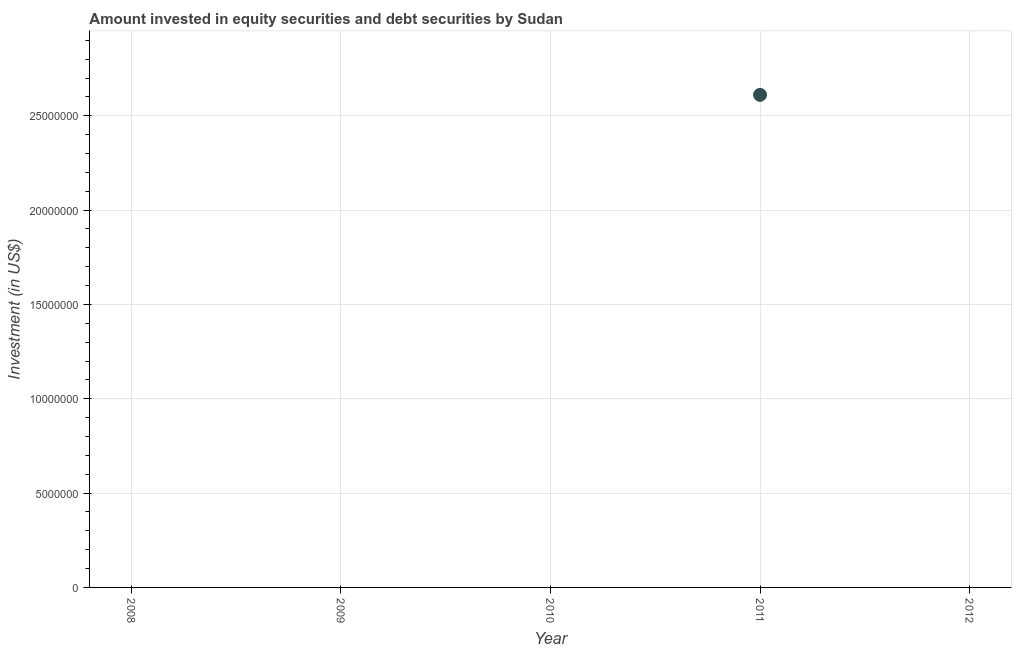Across all years, what is the maximum portfolio investment?
Provide a short and direct response. 2.61e+07. Across all years, what is the minimum portfolio investment?
Provide a succinct answer. 0. What is the sum of the portfolio investment?
Provide a short and direct response. 2.61e+07. What is the average portfolio investment per year?
Ensure brevity in your answer.  5.22e+06. In how many years, is the portfolio investment greater than 7000000 US$?
Provide a succinct answer. 1. What is the difference between the highest and the lowest portfolio investment?
Provide a succinct answer. 2.61e+07. Does the portfolio investment monotonically increase over the years?
Give a very brief answer. No. How many years are there in the graph?
Give a very brief answer. 5. Does the graph contain any zero values?
Ensure brevity in your answer.  Yes. What is the title of the graph?
Keep it short and to the point. Amount invested in equity securities and debt securities by Sudan. What is the label or title of the Y-axis?
Your answer should be very brief. Investment (in US$). What is the Investment (in US$) in 2009?
Keep it short and to the point. 0. What is the Investment (in US$) in 2011?
Your response must be concise. 2.61e+07. What is the Investment (in US$) in 2012?
Keep it short and to the point. 0. 